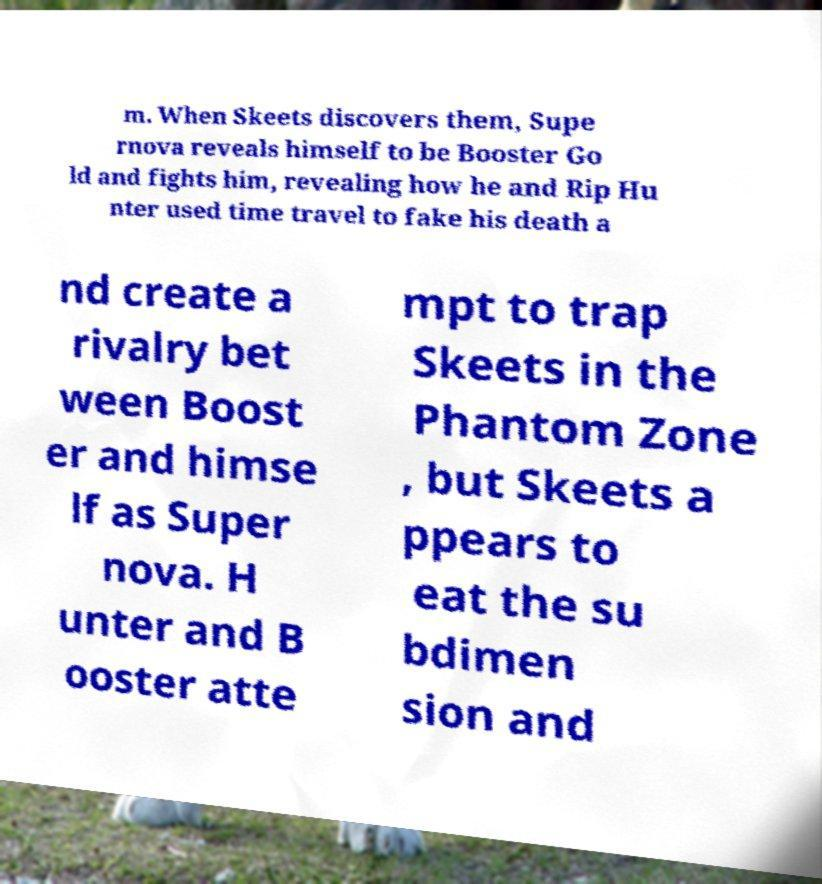There's text embedded in this image that I need extracted. Can you transcribe it verbatim? m. When Skeets discovers them, Supe rnova reveals himself to be Booster Go ld and fights him, revealing how he and Rip Hu nter used time travel to fake his death a nd create a rivalry bet ween Boost er and himse lf as Super nova. H unter and B ooster atte mpt to trap Skeets in the Phantom Zone , but Skeets a ppears to eat the su bdimen sion and 